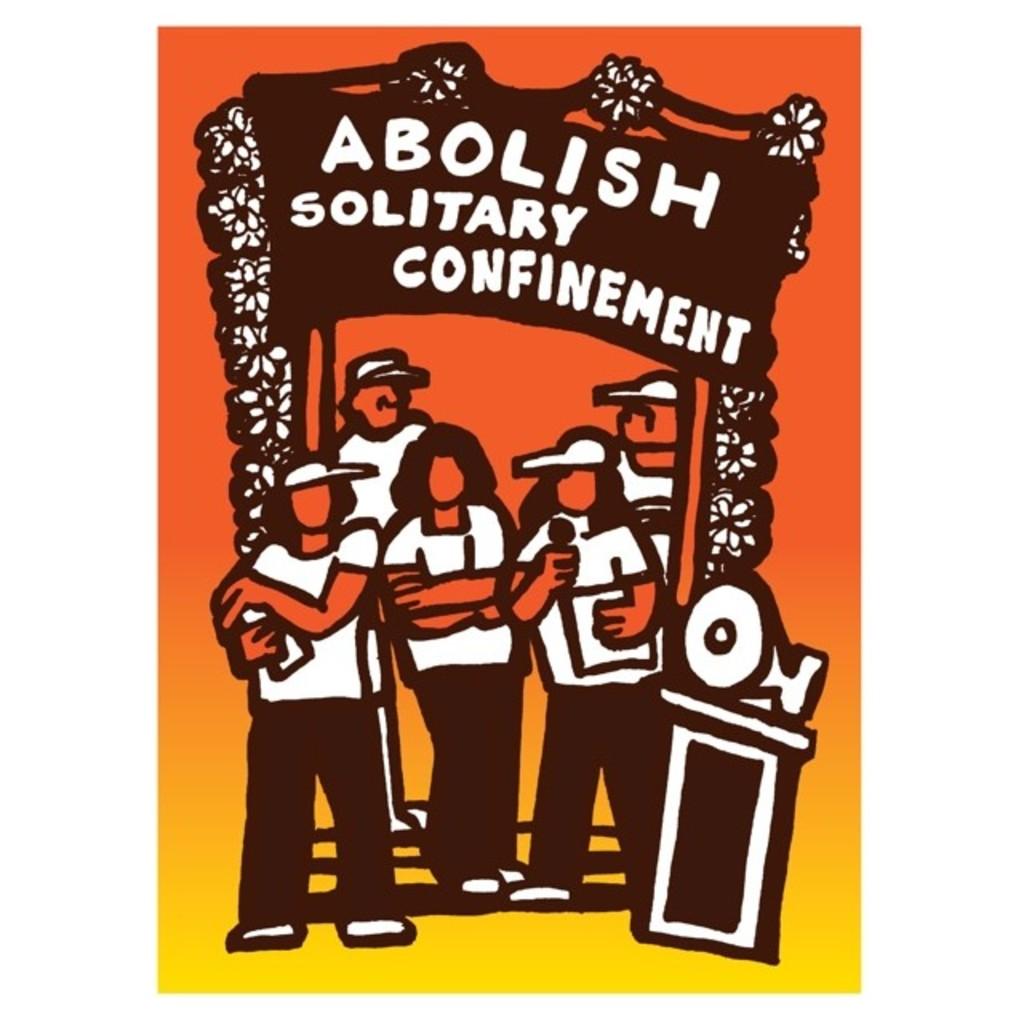What does the sign tell you to abolish?
Your response must be concise. Solitary confinement. What kind of confinement?
Offer a terse response. Solitary. 